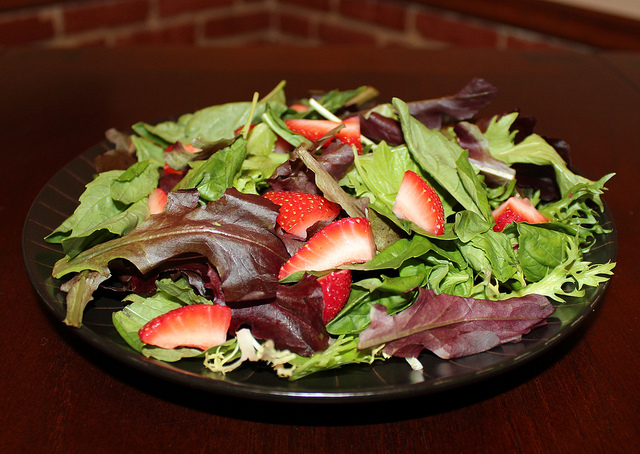What orange vegetable is in the bowl? Actually, there aren't any orange vegetables visible in the image. The bowl contains a fresh salad with various greens and sliced strawberries. 